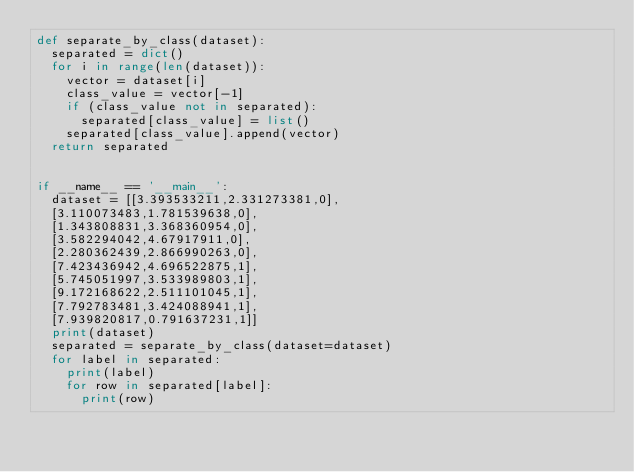Convert code to text. <code><loc_0><loc_0><loc_500><loc_500><_Python_>def separate_by_class(dataset):
	separated = dict()
	for i in range(len(dataset)):
		vector = dataset[i]
		class_value = vector[-1]
		if (class_value not in separated):
			separated[class_value] = list()
		separated[class_value].append(vector)
	return separated


if __name__ == '__main__':
	dataset = [[3.393533211,2.331273381,0],
	[3.110073483,1.781539638,0],
	[1.343808831,3.368360954,0],
	[3.582294042,4.67917911,0],
	[2.280362439,2.866990263,0],
	[7.423436942,4.696522875,1],
	[5.745051997,3.533989803,1],
	[9.172168622,2.511101045,1],
	[7.792783481,3.424088941,1],
	[7.939820817,0.791637231,1]]
	print(dataset)
	separated = separate_by_class(dataset=dataset)
	for label in separated:
		print(label)
		for row in separated[label]:
			print(row)</code> 